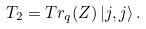Convert formula to latex. <formula><loc_0><loc_0><loc_500><loc_500>T _ { 2 } = T r _ { q } ( Z ) \left | j , j \right \rangle .</formula> 